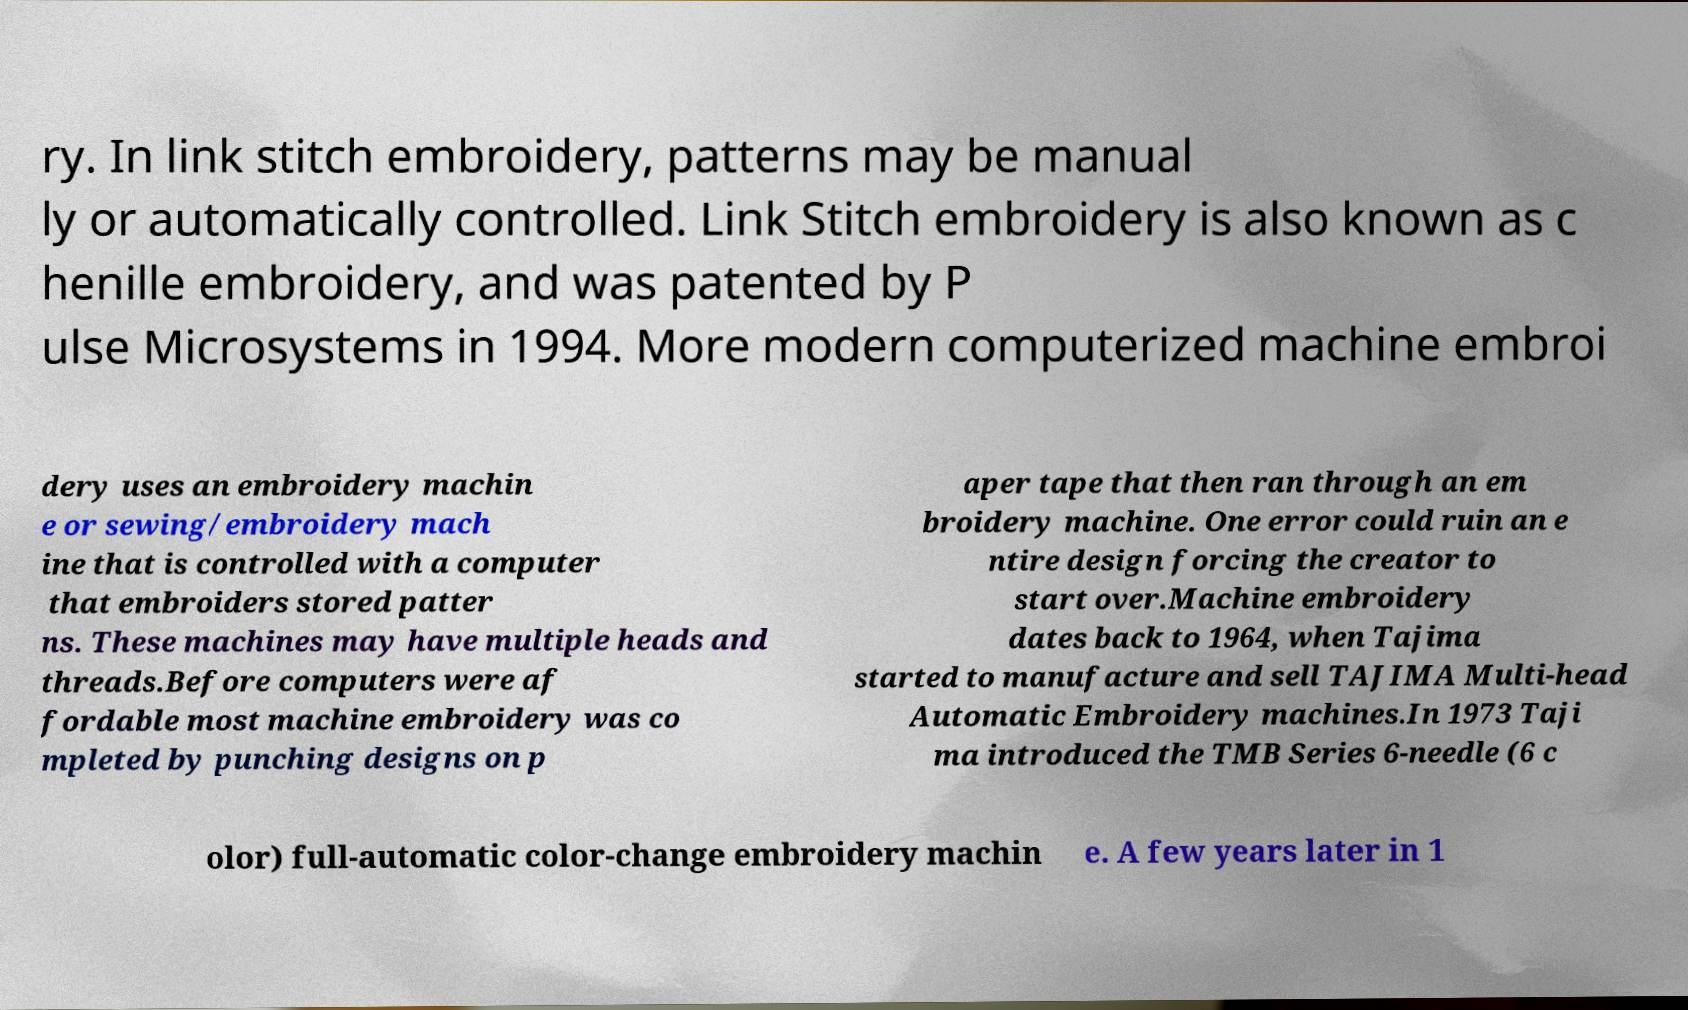Can you read and provide the text displayed in the image?This photo seems to have some interesting text. Can you extract and type it out for me? ry. In link stitch embroidery, patterns may be manual ly or automatically controlled. Link Stitch embroidery is also known as c henille embroidery, and was patented by P ulse Microsystems in 1994. More modern computerized machine embroi dery uses an embroidery machin e or sewing/embroidery mach ine that is controlled with a computer that embroiders stored patter ns. These machines may have multiple heads and threads.Before computers were af fordable most machine embroidery was co mpleted by punching designs on p aper tape that then ran through an em broidery machine. One error could ruin an e ntire design forcing the creator to start over.Machine embroidery dates back to 1964, when Tajima started to manufacture and sell TAJIMA Multi-head Automatic Embroidery machines.In 1973 Taji ma introduced the TMB Series 6-needle (6 c olor) full-automatic color-change embroidery machin e. A few years later in 1 